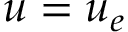Convert formula to latex. <formula><loc_0><loc_0><loc_500><loc_500>u = u _ { e }</formula> 